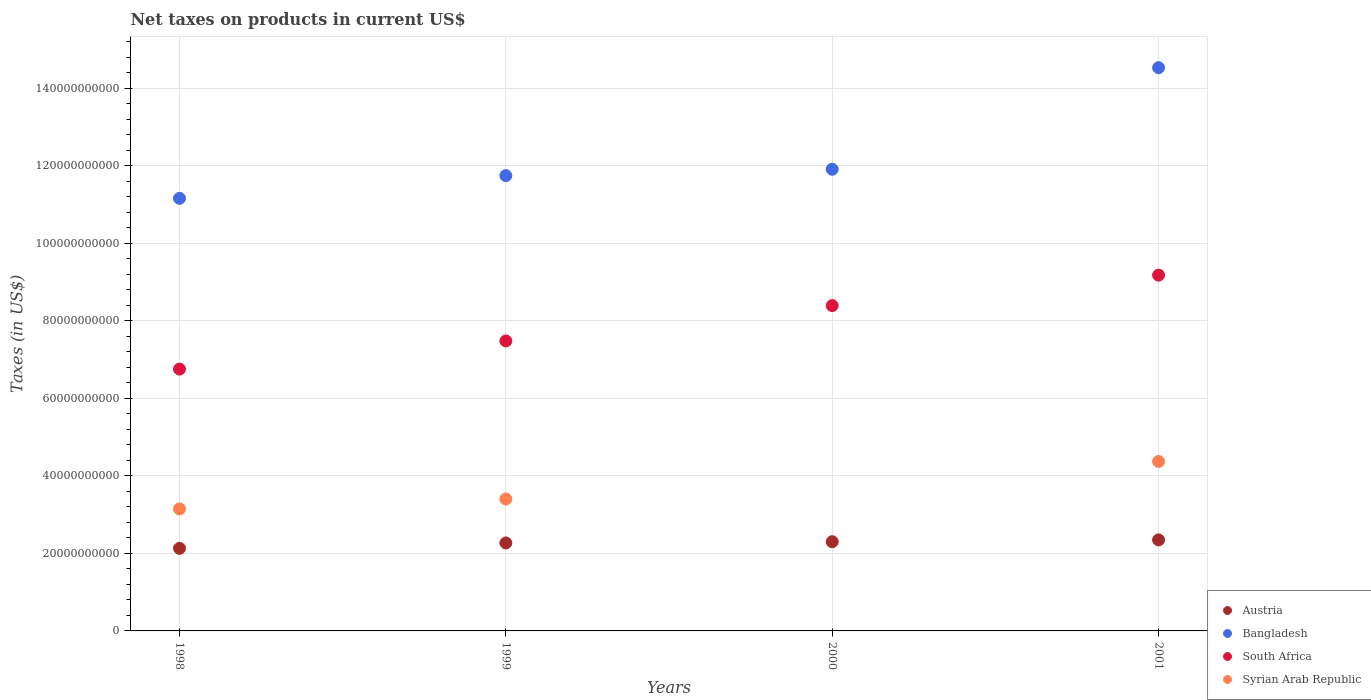What is the net taxes on products in Bangladesh in 1999?
Ensure brevity in your answer.  1.17e+11. Across all years, what is the maximum net taxes on products in Bangladesh?
Offer a terse response. 1.45e+11. Across all years, what is the minimum net taxes on products in Syrian Arab Republic?
Your response must be concise. 0. In which year was the net taxes on products in South Africa maximum?
Your response must be concise. 2001. What is the total net taxes on products in Bangladesh in the graph?
Your response must be concise. 4.93e+11. What is the difference between the net taxes on products in Austria in 1998 and that in 1999?
Make the answer very short. -1.39e+09. What is the difference between the net taxes on products in South Africa in 1998 and the net taxes on products in Bangladesh in 2000?
Keep it short and to the point. -5.16e+1. What is the average net taxes on products in Austria per year?
Keep it short and to the point. 2.26e+1. In the year 1998, what is the difference between the net taxes on products in Syrian Arab Republic and net taxes on products in Austria?
Offer a terse response. 1.02e+1. What is the ratio of the net taxes on products in South Africa in 1998 to that in 2000?
Make the answer very short. 0.8. What is the difference between the highest and the second highest net taxes on products in South Africa?
Offer a terse response. 7.86e+09. What is the difference between the highest and the lowest net taxes on products in Syrian Arab Republic?
Provide a short and direct response. 4.37e+1. Is the sum of the net taxes on products in Bangladesh in 2000 and 2001 greater than the maximum net taxes on products in South Africa across all years?
Offer a terse response. Yes. Is it the case that in every year, the sum of the net taxes on products in Bangladesh and net taxes on products in Austria  is greater than the net taxes on products in South Africa?
Make the answer very short. Yes. Is the net taxes on products in Syrian Arab Republic strictly less than the net taxes on products in Bangladesh over the years?
Keep it short and to the point. Yes. How many years are there in the graph?
Ensure brevity in your answer.  4. What is the difference between two consecutive major ticks on the Y-axis?
Give a very brief answer. 2.00e+1. Are the values on the major ticks of Y-axis written in scientific E-notation?
Keep it short and to the point. No. Does the graph contain grids?
Your response must be concise. Yes. What is the title of the graph?
Provide a succinct answer. Net taxes on products in current US$. Does "Tonga" appear as one of the legend labels in the graph?
Give a very brief answer. No. What is the label or title of the Y-axis?
Provide a short and direct response. Taxes (in US$). What is the Taxes (in US$) in Austria in 1998?
Offer a terse response. 2.13e+1. What is the Taxes (in US$) of Bangladesh in 1998?
Provide a short and direct response. 1.12e+11. What is the Taxes (in US$) in South Africa in 1998?
Offer a terse response. 6.75e+1. What is the Taxes (in US$) of Syrian Arab Republic in 1998?
Keep it short and to the point. 3.15e+1. What is the Taxes (in US$) of Austria in 1999?
Offer a terse response. 2.27e+1. What is the Taxes (in US$) of Bangladesh in 1999?
Provide a short and direct response. 1.17e+11. What is the Taxes (in US$) in South Africa in 1999?
Keep it short and to the point. 7.48e+1. What is the Taxes (in US$) of Syrian Arab Republic in 1999?
Your response must be concise. 3.40e+1. What is the Taxes (in US$) in Austria in 2000?
Your answer should be compact. 2.30e+1. What is the Taxes (in US$) of Bangladesh in 2000?
Provide a short and direct response. 1.19e+11. What is the Taxes (in US$) of South Africa in 2000?
Provide a succinct answer. 8.39e+1. What is the Taxes (in US$) of Syrian Arab Republic in 2000?
Give a very brief answer. 0. What is the Taxes (in US$) of Austria in 2001?
Your response must be concise. 2.35e+1. What is the Taxes (in US$) in Bangladesh in 2001?
Provide a short and direct response. 1.45e+11. What is the Taxes (in US$) of South Africa in 2001?
Provide a succinct answer. 9.18e+1. What is the Taxes (in US$) in Syrian Arab Republic in 2001?
Offer a very short reply. 4.37e+1. Across all years, what is the maximum Taxes (in US$) in Austria?
Ensure brevity in your answer.  2.35e+1. Across all years, what is the maximum Taxes (in US$) in Bangladesh?
Keep it short and to the point. 1.45e+11. Across all years, what is the maximum Taxes (in US$) in South Africa?
Keep it short and to the point. 9.18e+1. Across all years, what is the maximum Taxes (in US$) in Syrian Arab Republic?
Your answer should be very brief. 4.37e+1. Across all years, what is the minimum Taxes (in US$) in Austria?
Make the answer very short. 2.13e+1. Across all years, what is the minimum Taxes (in US$) of Bangladesh?
Offer a very short reply. 1.12e+11. Across all years, what is the minimum Taxes (in US$) in South Africa?
Provide a short and direct response. 6.75e+1. Across all years, what is the minimum Taxes (in US$) in Syrian Arab Republic?
Provide a succinct answer. 0. What is the total Taxes (in US$) in Austria in the graph?
Keep it short and to the point. 9.05e+1. What is the total Taxes (in US$) of Bangladesh in the graph?
Your answer should be compact. 4.93e+11. What is the total Taxes (in US$) in South Africa in the graph?
Keep it short and to the point. 3.18e+11. What is the total Taxes (in US$) of Syrian Arab Republic in the graph?
Your response must be concise. 1.09e+11. What is the difference between the Taxes (in US$) of Austria in 1998 and that in 1999?
Keep it short and to the point. -1.39e+09. What is the difference between the Taxes (in US$) of Bangladesh in 1998 and that in 1999?
Provide a succinct answer. -5.85e+09. What is the difference between the Taxes (in US$) in South Africa in 1998 and that in 1999?
Your response must be concise. -7.26e+09. What is the difference between the Taxes (in US$) in Syrian Arab Republic in 1998 and that in 1999?
Give a very brief answer. -2.56e+09. What is the difference between the Taxes (in US$) in Austria in 1998 and that in 2000?
Make the answer very short. -1.71e+09. What is the difference between the Taxes (in US$) in Bangladesh in 1998 and that in 2000?
Your response must be concise. -7.50e+09. What is the difference between the Taxes (in US$) in South Africa in 1998 and that in 2000?
Your answer should be compact. -1.64e+1. What is the difference between the Taxes (in US$) in Austria in 1998 and that in 2001?
Ensure brevity in your answer.  -2.18e+09. What is the difference between the Taxes (in US$) of Bangladesh in 1998 and that in 2001?
Give a very brief answer. -3.37e+1. What is the difference between the Taxes (in US$) of South Africa in 1998 and that in 2001?
Give a very brief answer. -2.42e+1. What is the difference between the Taxes (in US$) in Syrian Arab Republic in 1998 and that in 2001?
Offer a terse response. -1.22e+1. What is the difference between the Taxes (in US$) of Austria in 1999 and that in 2000?
Make the answer very short. -3.20e+08. What is the difference between the Taxes (in US$) of Bangladesh in 1999 and that in 2000?
Ensure brevity in your answer.  -1.65e+09. What is the difference between the Taxes (in US$) of South Africa in 1999 and that in 2000?
Keep it short and to the point. -9.12e+09. What is the difference between the Taxes (in US$) of Austria in 1999 and that in 2001?
Make the answer very short. -7.87e+08. What is the difference between the Taxes (in US$) of Bangladesh in 1999 and that in 2001?
Ensure brevity in your answer.  -2.78e+1. What is the difference between the Taxes (in US$) in South Africa in 1999 and that in 2001?
Offer a very short reply. -1.70e+1. What is the difference between the Taxes (in US$) in Syrian Arab Republic in 1999 and that in 2001?
Provide a succinct answer. -9.69e+09. What is the difference between the Taxes (in US$) of Austria in 2000 and that in 2001?
Your response must be concise. -4.67e+08. What is the difference between the Taxes (in US$) of Bangladesh in 2000 and that in 2001?
Offer a terse response. -2.62e+1. What is the difference between the Taxes (in US$) of South Africa in 2000 and that in 2001?
Offer a very short reply. -7.86e+09. What is the difference between the Taxes (in US$) in Austria in 1998 and the Taxes (in US$) in Bangladesh in 1999?
Your answer should be very brief. -9.62e+1. What is the difference between the Taxes (in US$) of Austria in 1998 and the Taxes (in US$) of South Africa in 1999?
Ensure brevity in your answer.  -5.35e+1. What is the difference between the Taxes (in US$) of Austria in 1998 and the Taxes (in US$) of Syrian Arab Republic in 1999?
Your answer should be compact. -1.27e+1. What is the difference between the Taxes (in US$) in Bangladesh in 1998 and the Taxes (in US$) in South Africa in 1999?
Your answer should be very brief. 3.68e+1. What is the difference between the Taxes (in US$) of Bangladesh in 1998 and the Taxes (in US$) of Syrian Arab Republic in 1999?
Offer a very short reply. 7.76e+1. What is the difference between the Taxes (in US$) of South Africa in 1998 and the Taxes (in US$) of Syrian Arab Republic in 1999?
Your response must be concise. 3.35e+1. What is the difference between the Taxes (in US$) of Austria in 1998 and the Taxes (in US$) of Bangladesh in 2000?
Keep it short and to the point. -9.78e+1. What is the difference between the Taxes (in US$) of Austria in 1998 and the Taxes (in US$) of South Africa in 2000?
Keep it short and to the point. -6.26e+1. What is the difference between the Taxes (in US$) in Bangladesh in 1998 and the Taxes (in US$) in South Africa in 2000?
Your answer should be very brief. 2.77e+1. What is the difference between the Taxes (in US$) in Austria in 1998 and the Taxes (in US$) in Bangladesh in 2001?
Give a very brief answer. -1.24e+11. What is the difference between the Taxes (in US$) of Austria in 1998 and the Taxes (in US$) of South Africa in 2001?
Ensure brevity in your answer.  -7.05e+1. What is the difference between the Taxes (in US$) in Austria in 1998 and the Taxes (in US$) in Syrian Arab Republic in 2001?
Give a very brief answer. -2.24e+1. What is the difference between the Taxes (in US$) in Bangladesh in 1998 and the Taxes (in US$) in South Africa in 2001?
Make the answer very short. 1.98e+1. What is the difference between the Taxes (in US$) of Bangladesh in 1998 and the Taxes (in US$) of Syrian Arab Republic in 2001?
Provide a short and direct response. 6.79e+1. What is the difference between the Taxes (in US$) of South Africa in 1998 and the Taxes (in US$) of Syrian Arab Republic in 2001?
Provide a succinct answer. 2.38e+1. What is the difference between the Taxes (in US$) in Austria in 1999 and the Taxes (in US$) in Bangladesh in 2000?
Ensure brevity in your answer.  -9.64e+1. What is the difference between the Taxes (in US$) in Austria in 1999 and the Taxes (in US$) in South Africa in 2000?
Ensure brevity in your answer.  -6.12e+1. What is the difference between the Taxes (in US$) of Bangladesh in 1999 and the Taxes (in US$) of South Africa in 2000?
Your answer should be compact. 3.35e+1. What is the difference between the Taxes (in US$) of Austria in 1999 and the Taxes (in US$) of Bangladesh in 2001?
Your answer should be very brief. -1.23e+11. What is the difference between the Taxes (in US$) in Austria in 1999 and the Taxes (in US$) in South Africa in 2001?
Offer a very short reply. -6.91e+1. What is the difference between the Taxes (in US$) of Austria in 1999 and the Taxes (in US$) of Syrian Arab Republic in 2001?
Offer a terse response. -2.10e+1. What is the difference between the Taxes (in US$) of Bangladesh in 1999 and the Taxes (in US$) of South Africa in 2001?
Keep it short and to the point. 2.57e+1. What is the difference between the Taxes (in US$) of Bangladesh in 1999 and the Taxes (in US$) of Syrian Arab Republic in 2001?
Your answer should be compact. 7.37e+1. What is the difference between the Taxes (in US$) in South Africa in 1999 and the Taxes (in US$) in Syrian Arab Republic in 2001?
Offer a terse response. 3.11e+1. What is the difference between the Taxes (in US$) in Austria in 2000 and the Taxes (in US$) in Bangladesh in 2001?
Ensure brevity in your answer.  -1.22e+11. What is the difference between the Taxes (in US$) in Austria in 2000 and the Taxes (in US$) in South Africa in 2001?
Offer a very short reply. -6.88e+1. What is the difference between the Taxes (in US$) of Austria in 2000 and the Taxes (in US$) of Syrian Arab Republic in 2001?
Provide a short and direct response. -2.07e+1. What is the difference between the Taxes (in US$) in Bangladesh in 2000 and the Taxes (in US$) in South Africa in 2001?
Your response must be concise. 2.73e+1. What is the difference between the Taxes (in US$) of Bangladesh in 2000 and the Taxes (in US$) of Syrian Arab Republic in 2001?
Your response must be concise. 7.54e+1. What is the difference between the Taxes (in US$) of South Africa in 2000 and the Taxes (in US$) of Syrian Arab Republic in 2001?
Provide a short and direct response. 4.02e+1. What is the average Taxes (in US$) of Austria per year?
Keep it short and to the point. 2.26e+1. What is the average Taxes (in US$) in Bangladesh per year?
Ensure brevity in your answer.  1.23e+11. What is the average Taxes (in US$) of South Africa per year?
Your answer should be very brief. 7.95e+1. What is the average Taxes (in US$) in Syrian Arab Republic per year?
Provide a short and direct response. 2.73e+1. In the year 1998, what is the difference between the Taxes (in US$) in Austria and Taxes (in US$) in Bangladesh?
Provide a succinct answer. -9.03e+1. In the year 1998, what is the difference between the Taxes (in US$) in Austria and Taxes (in US$) in South Africa?
Keep it short and to the point. -4.62e+1. In the year 1998, what is the difference between the Taxes (in US$) in Austria and Taxes (in US$) in Syrian Arab Republic?
Offer a very short reply. -1.02e+1. In the year 1998, what is the difference between the Taxes (in US$) in Bangladesh and Taxes (in US$) in South Africa?
Ensure brevity in your answer.  4.41e+1. In the year 1998, what is the difference between the Taxes (in US$) of Bangladesh and Taxes (in US$) of Syrian Arab Republic?
Your answer should be compact. 8.01e+1. In the year 1998, what is the difference between the Taxes (in US$) of South Africa and Taxes (in US$) of Syrian Arab Republic?
Your response must be concise. 3.61e+1. In the year 1999, what is the difference between the Taxes (in US$) in Austria and Taxes (in US$) in Bangladesh?
Provide a short and direct response. -9.48e+1. In the year 1999, what is the difference between the Taxes (in US$) of Austria and Taxes (in US$) of South Africa?
Provide a succinct answer. -5.21e+1. In the year 1999, what is the difference between the Taxes (in US$) in Austria and Taxes (in US$) in Syrian Arab Republic?
Your answer should be very brief. -1.13e+1. In the year 1999, what is the difference between the Taxes (in US$) in Bangladesh and Taxes (in US$) in South Africa?
Offer a very short reply. 4.27e+1. In the year 1999, what is the difference between the Taxes (in US$) of Bangladesh and Taxes (in US$) of Syrian Arab Republic?
Provide a short and direct response. 8.34e+1. In the year 1999, what is the difference between the Taxes (in US$) in South Africa and Taxes (in US$) in Syrian Arab Republic?
Your answer should be compact. 4.08e+1. In the year 2000, what is the difference between the Taxes (in US$) in Austria and Taxes (in US$) in Bangladesh?
Your answer should be compact. -9.61e+1. In the year 2000, what is the difference between the Taxes (in US$) in Austria and Taxes (in US$) in South Africa?
Your answer should be compact. -6.09e+1. In the year 2000, what is the difference between the Taxes (in US$) of Bangladesh and Taxes (in US$) of South Africa?
Ensure brevity in your answer.  3.52e+1. In the year 2001, what is the difference between the Taxes (in US$) in Austria and Taxes (in US$) in Bangladesh?
Your response must be concise. -1.22e+11. In the year 2001, what is the difference between the Taxes (in US$) of Austria and Taxes (in US$) of South Africa?
Offer a terse response. -6.83e+1. In the year 2001, what is the difference between the Taxes (in US$) of Austria and Taxes (in US$) of Syrian Arab Republic?
Give a very brief answer. -2.02e+1. In the year 2001, what is the difference between the Taxes (in US$) of Bangladesh and Taxes (in US$) of South Africa?
Provide a short and direct response. 5.35e+1. In the year 2001, what is the difference between the Taxes (in US$) of Bangladesh and Taxes (in US$) of Syrian Arab Republic?
Your answer should be compact. 1.02e+11. In the year 2001, what is the difference between the Taxes (in US$) of South Africa and Taxes (in US$) of Syrian Arab Republic?
Offer a very short reply. 4.81e+1. What is the ratio of the Taxes (in US$) of Austria in 1998 to that in 1999?
Make the answer very short. 0.94. What is the ratio of the Taxes (in US$) of Bangladesh in 1998 to that in 1999?
Provide a short and direct response. 0.95. What is the ratio of the Taxes (in US$) in South Africa in 1998 to that in 1999?
Give a very brief answer. 0.9. What is the ratio of the Taxes (in US$) in Syrian Arab Republic in 1998 to that in 1999?
Provide a short and direct response. 0.92. What is the ratio of the Taxes (in US$) of Austria in 1998 to that in 2000?
Make the answer very short. 0.93. What is the ratio of the Taxes (in US$) of Bangladesh in 1998 to that in 2000?
Your response must be concise. 0.94. What is the ratio of the Taxes (in US$) in South Africa in 1998 to that in 2000?
Provide a short and direct response. 0.8. What is the ratio of the Taxes (in US$) of Austria in 1998 to that in 2001?
Offer a very short reply. 0.91. What is the ratio of the Taxes (in US$) of Bangladesh in 1998 to that in 2001?
Ensure brevity in your answer.  0.77. What is the ratio of the Taxes (in US$) of South Africa in 1998 to that in 2001?
Make the answer very short. 0.74. What is the ratio of the Taxes (in US$) of Syrian Arab Republic in 1998 to that in 2001?
Offer a terse response. 0.72. What is the ratio of the Taxes (in US$) of Austria in 1999 to that in 2000?
Offer a very short reply. 0.99. What is the ratio of the Taxes (in US$) of Bangladesh in 1999 to that in 2000?
Give a very brief answer. 0.99. What is the ratio of the Taxes (in US$) of South Africa in 1999 to that in 2000?
Offer a very short reply. 0.89. What is the ratio of the Taxes (in US$) in Austria in 1999 to that in 2001?
Provide a short and direct response. 0.97. What is the ratio of the Taxes (in US$) in Bangladesh in 1999 to that in 2001?
Your answer should be very brief. 0.81. What is the ratio of the Taxes (in US$) of South Africa in 1999 to that in 2001?
Provide a succinct answer. 0.81. What is the ratio of the Taxes (in US$) in Syrian Arab Republic in 1999 to that in 2001?
Offer a very short reply. 0.78. What is the ratio of the Taxes (in US$) in Austria in 2000 to that in 2001?
Give a very brief answer. 0.98. What is the ratio of the Taxes (in US$) of Bangladesh in 2000 to that in 2001?
Keep it short and to the point. 0.82. What is the ratio of the Taxes (in US$) in South Africa in 2000 to that in 2001?
Your answer should be very brief. 0.91. What is the difference between the highest and the second highest Taxes (in US$) in Austria?
Your answer should be compact. 4.67e+08. What is the difference between the highest and the second highest Taxes (in US$) in Bangladesh?
Provide a succinct answer. 2.62e+1. What is the difference between the highest and the second highest Taxes (in US$) of South Africa?
Your answer should be compact. 7.86e+09. What is the difference between the highest and the second highest Taxes (in US$) of Syrian Arab Republic?
Your answer should be compact. 9.69e+09. What is the difference between the highest and the lowest Taxes (in US$) in Austria?
Offer a terse response. 2.18e+09. What is the difference between the highest and the lowest Taxes (in US$) of Bangladesh?
Make the answer very short. 3.37e+1. What is the difference between the highest and the lowest Taxes (in US$) in South Africa?
Offer a very short reply. 2.42e+1. What is the difference between the highest and the lowest Taxes (in US$) in Syrian Arab Republic?
Your answer should be compact. 4.37e+1. 